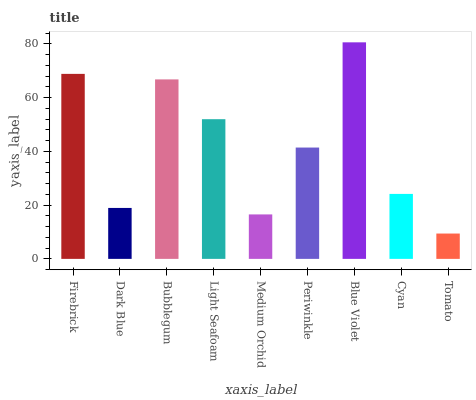Is Tomato the minimum?
Answer yes or no. Yes. Is Blue Violet the maximum?
Answer yes or no. Yes. Is Dark Blue the minimum?
Answer yes or no. No. Is Dark Blue the maximum?
Answer yes or no. No. Is Firebrick greater than Dark Blue?
Answer yes or no. Yes. Is Dark Blue less than Firebrick?
Answer yes or no. Yes. Is Dark Blue greater than Firebrick?
Answer yes or no. No. Is Firebrick less than Dark Blue?
Answer yes or no. No. Is Periwinkle the high median?
Answer yes or no. Yes. Is Periwinkle the low median?
Answer yes or no. Yes. Is Light Seafoam the high median?
Answer yes or no. No. Is Tomato the low median?
Answer yes or no. No. 